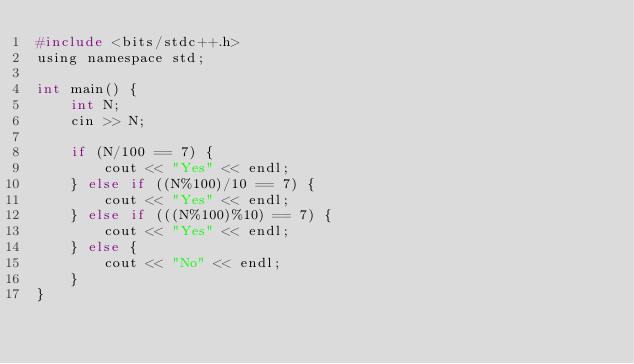<code> <loc_0><loc_0><loc_500><loc_500><_C_>#include <bits/stdc++.h>
using namespace std;

int main() {
    int N;
    cin >> N;

    if (N/100 == 7) {
        cout << "Yes" << endl;
    } else if ((N%100)/10 == 7) {
        cout << "Yes" << endl;
    } else if (((N%100)%10) == 7) {
        cout << "Yes" << endl; 
    } else {
        cout << "No" << endl;
    }
}</code> 